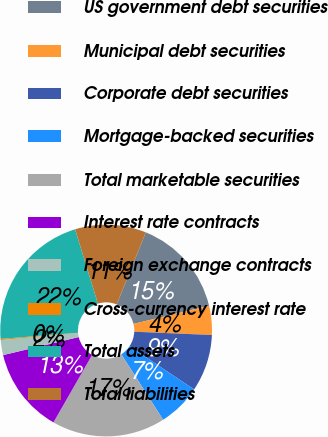Convert chart. <chart><loc_0><loc_0><loc_500><loc_500><pie_chart><fcel>US government debt securities<fcel>Municipal debt securities<fcel>Corporate debt securities<fcel>Mortgage-backed securities<fcel>Total marketable securities<fcel>Interest rate contracts<fcel>Foreign exchange contracts<fcel>Cross-currency interest rate<fcel>Total assets<fcel>Total liabilities<nl><fcel>15.12%<fcel>4.44%<fcel>8.71%<fcel>6.57%<fcel>17.33%<fcel>12.99%<fcel>2.3%<fcel>0.16%<fcel>21.54%<fcel>10.85%<nl></chart> 